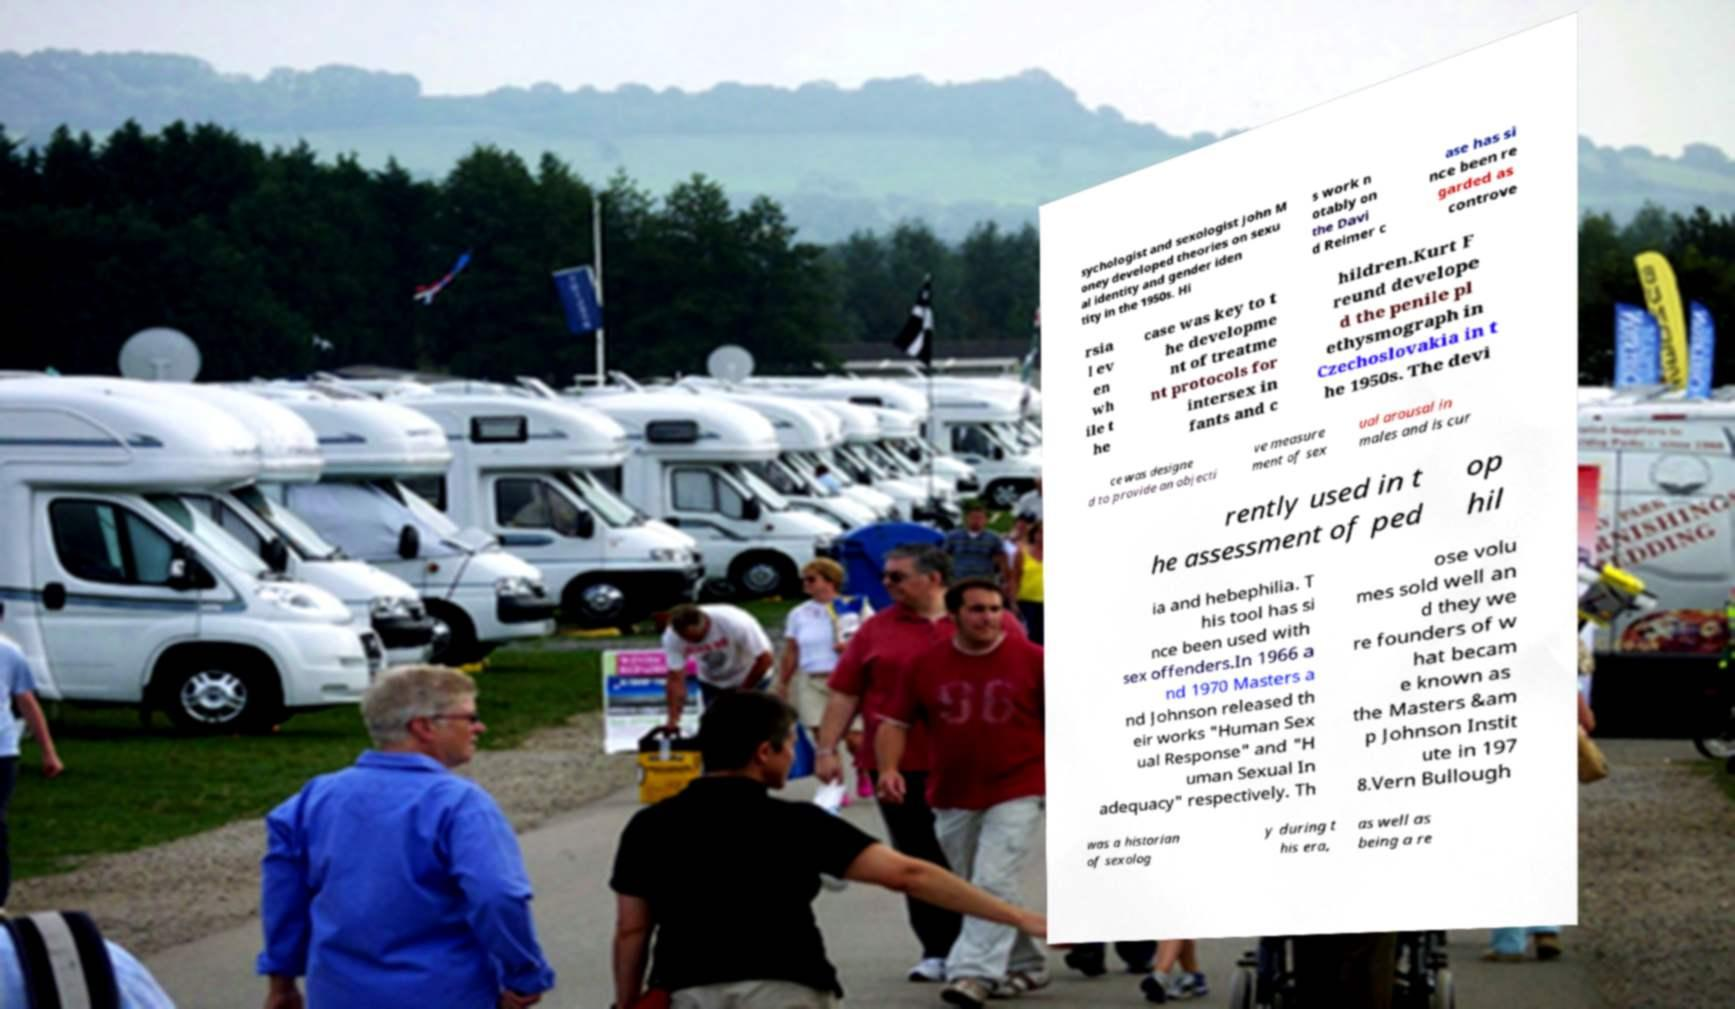Please identify and transcribe the text found in this image. sychologist and sexologist John M oney developed theories on sexu al identity and gender iden tity in the 1950s. Hi s work n otably on the Davi d Reimer c ase has si nce been re garded as controve rsia l ev en wh ile t he case was key to t he developme nt of treatme nt protocols for intersex in fants and c hildren.Kurt F reund develope d the penile pl ethysmograph in Czechoslovakia in t he 1950s. The devi ce was designe d to provide an objecti ve measure ment of sex ual arousal in males and is cur rently used in t he assessment of ped op hil ia and hebephilia. T his tool has si nce been used with sex offenders.In 1966 a nd 1970 Masters a nd Johnson released th eir works "Human Sex ual Response" and "H uman Sexual In adequacy" respectively. Th ose volu mes sold well an d they we re founders of w hat becam e known as the Masters &am p Johnson Instit ute in 197 8.Vern Bullough was a historian of sexolog y during t his era, as well as being a re 